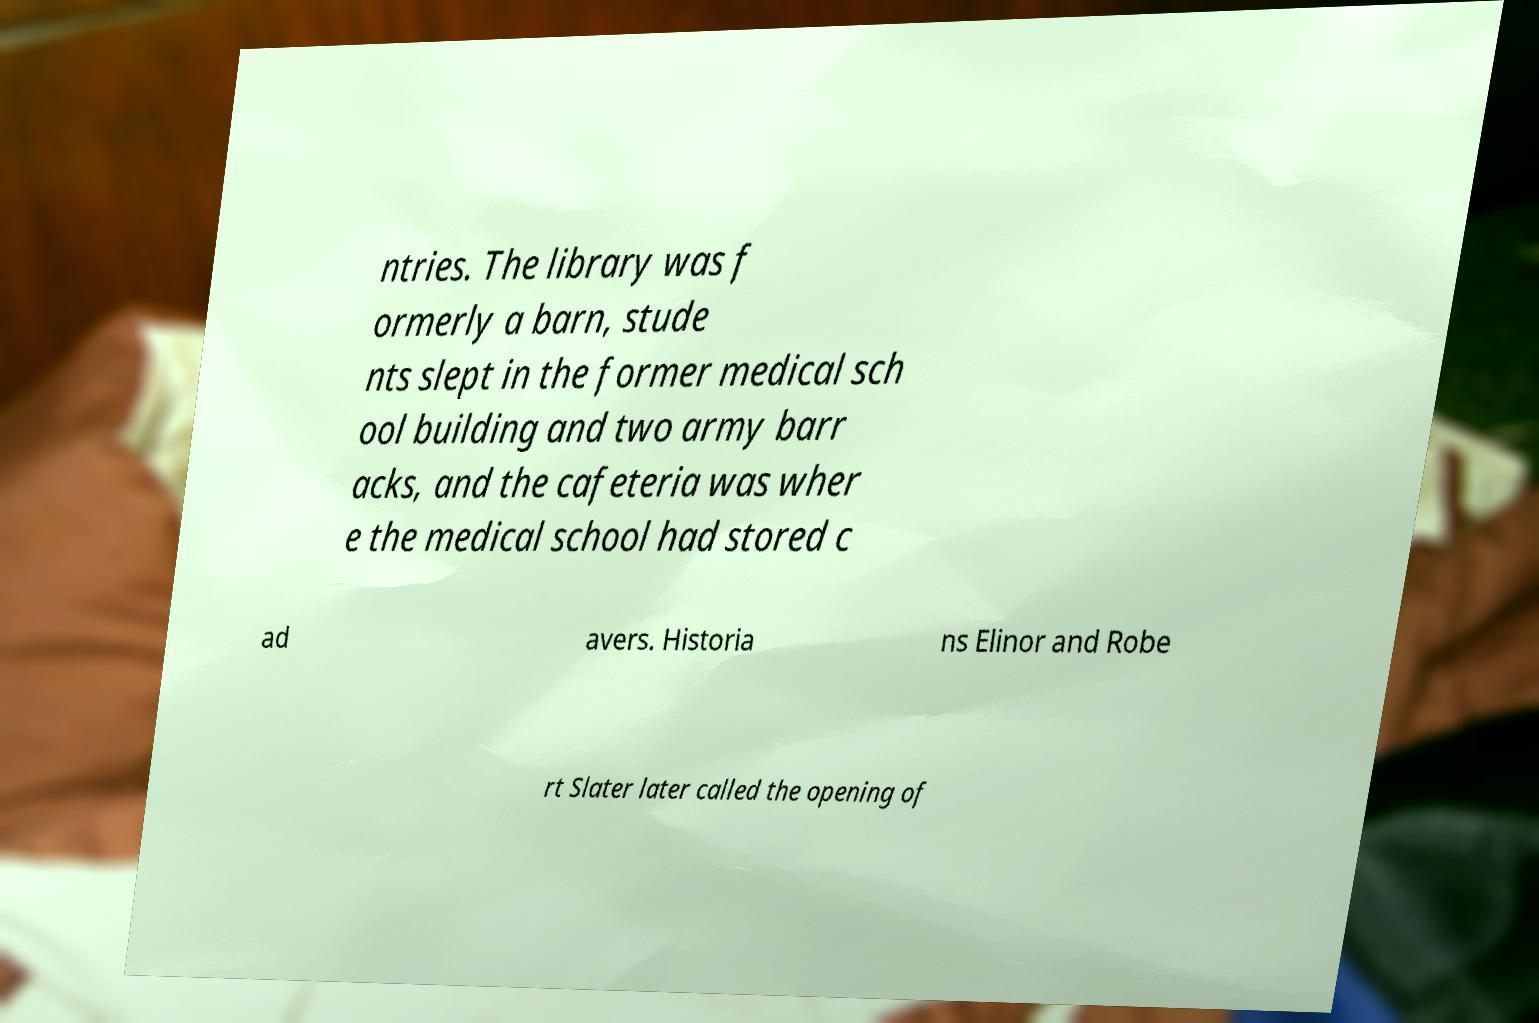For documentation purposes, I need the text within this image transcribed. Could you provide that? ntries. The library was f ormerly a barn, stude nts slept in the former medical sch ool building and two army barr acks, and the cafeteria was wher e the medical school had stored c ad avers. Historia ns Elinor and Robe rt Slater later called the opening of 